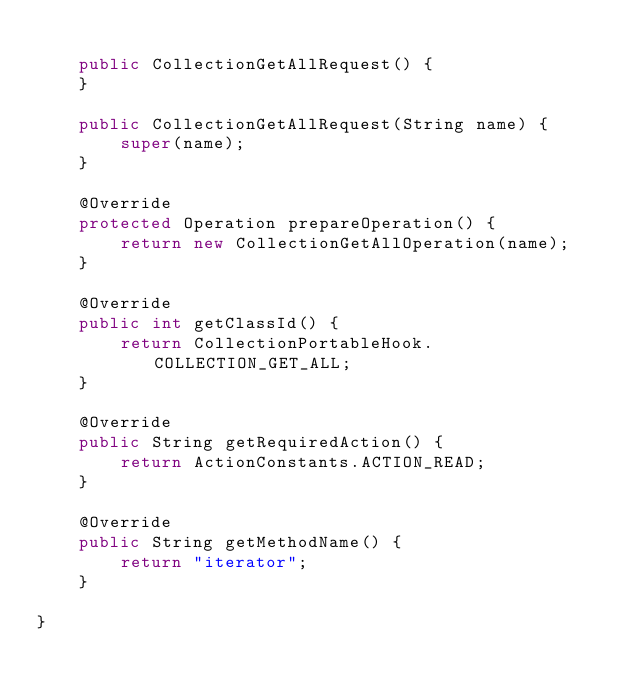Convert code to text. <code><loc_0><loc_0><loc_500><loc_500><_Java_>
    public CollectionGetAllRequest() {
    }

    public CollectionGetAllRequest(String name) {
        super(name);
    }

    @Override
    protected Operation prepareOperation() {
        return new CollectionGetAllOperation(name);
    }

    @Override
    public int getClassId() {
        return CollectionPortableHook.COLLECTION_GET_ALL;
    }

    @Override
    public String getRequiredAction() {
        return ActionConstants.ACTION_READ;
    }

    @Override
    public String getMethodName() {
        return "iterator";
    }

}
</code> 